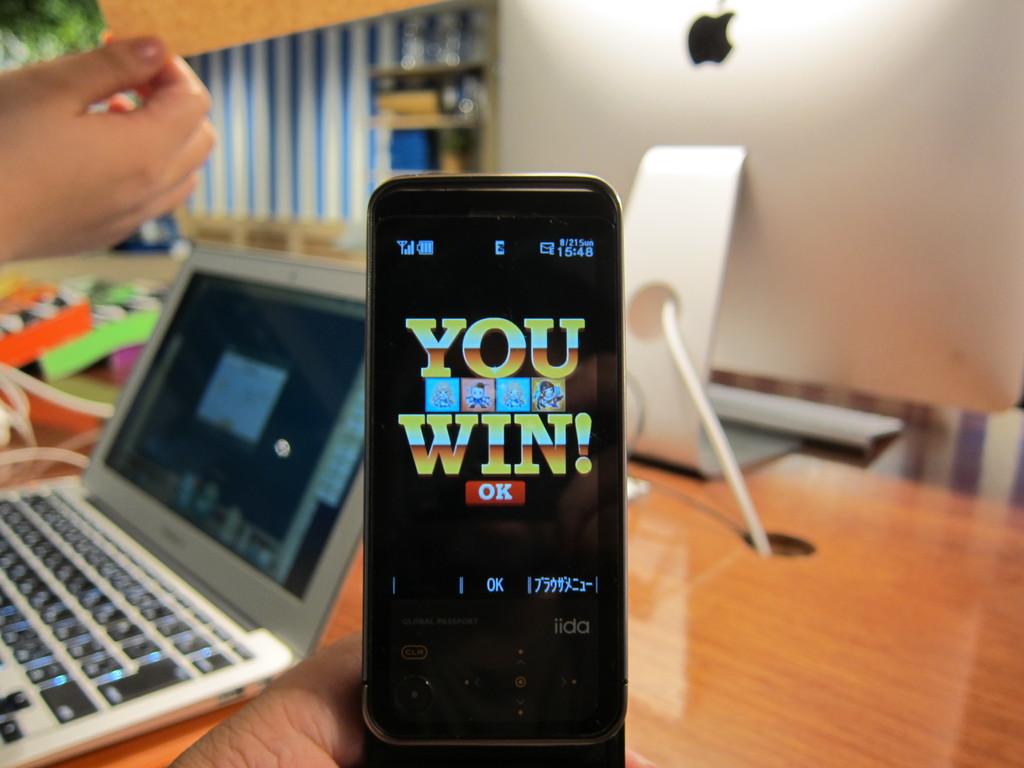Who manufactured the phone?
Give a very brief answer. Iida. 